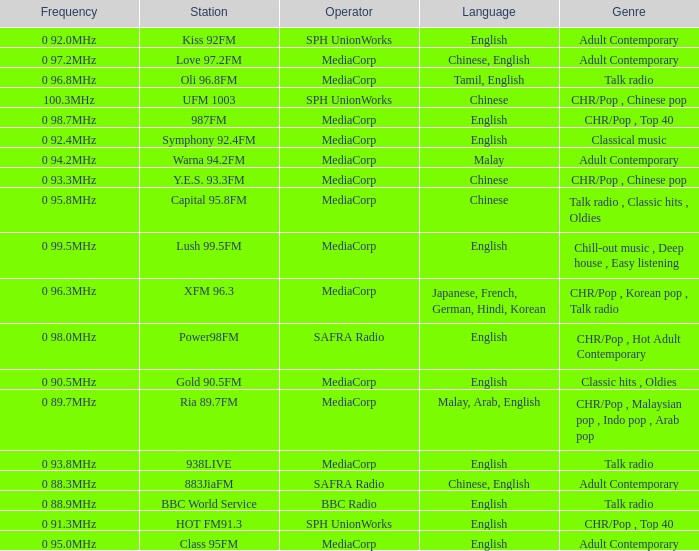What genre has a station of Class 95FM? Adult Contemporary. 